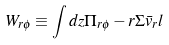<formula> <loc_0><loc_0><loc_500><loc_500>W _ { r \phi } \equiv \int d z \Pi _ { r \phi } - r \Sigma \bar { v } _ { r } l</formula> 